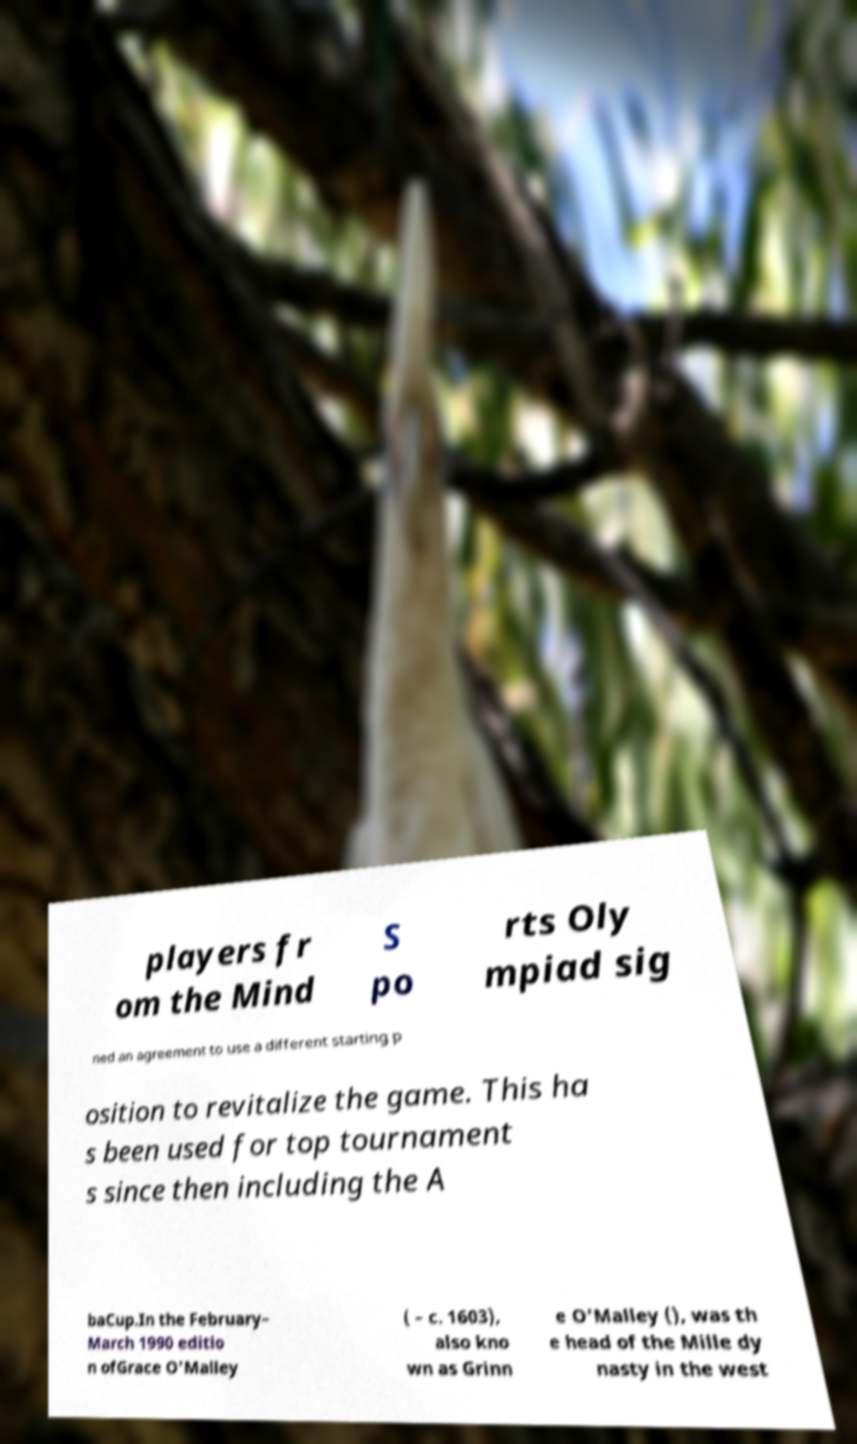Could you assist in decoding the text presented in this image and type it out clearly? players fr om the Mind S po rts Oly mpiad sig ned an agreement to use a different starting p osition to revitalize the game. This ha s been used for top tournament s since then including the A baCup.In the February– March 1990 editio n ofGrace O'Malley ( – c. 1603), also kno wn as Grinn e O'Malley (), was th e head of the Mille dy nasty in the west 